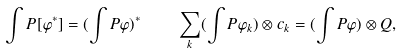Convert formula to latex. <formula><loc_0><loc_0><loc_500><loc_500>\int P [ \varphi ^ { * } ] = ( \int P \varphi ) ^ { * } \quad \sum _ { k } ( \int P \varphi _ { k } ) \otimes c _ { k } = ( \int P \varphi ) \otimes Q ,</formula> 